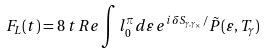Convert formula to latex. <formula><loc_0><loc_0><loc_500><loc_500>F _ { L } ( t ) = 8 \, t \, R e \int l _ { 0 } ^ { \pi } d \varepsilon \, e ^ { i \, \delta S _ { \gamma , \gamma _ { \times } } / } \tilde { P } ( \varepsilon , T _ { \gamma } )</formula> 